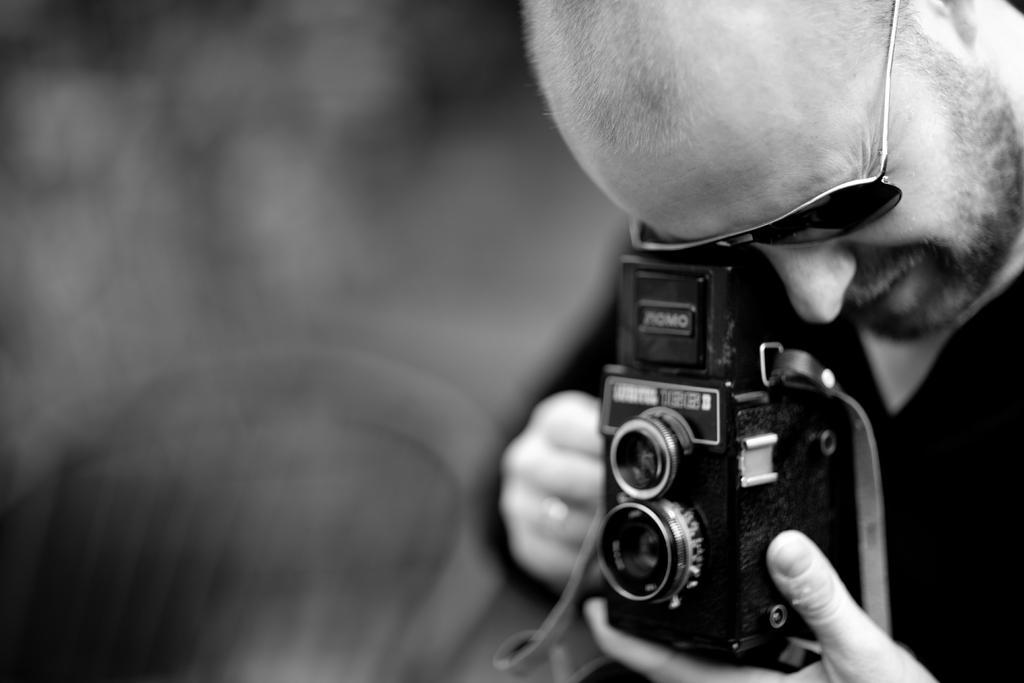Describe this image in one or two sentences. In this picture there is a man holding a camera in his hand. 